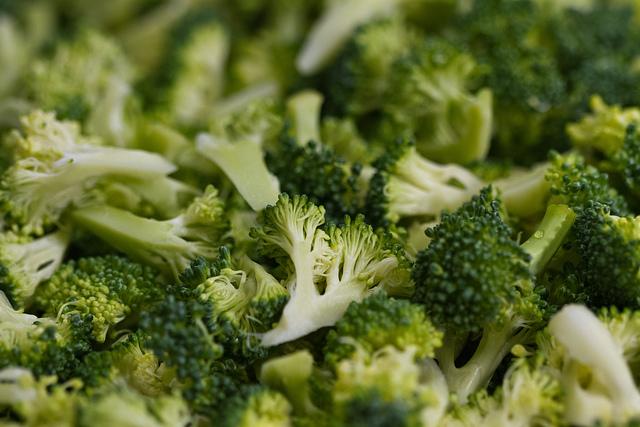Is there sauce on the broccoli?
Write a very short answer. No. How many bugs are in this picture?
Be succinct. 0. Is this a fruit?
Write a very short answer. No. What kind of food is this?
Give a very brief answer. Broccoli. Is there ice in the image?
Write a very short answer. No. Is the broccoli fresh?
Write a very short answer. Yes. What vegetable is this?
Answer briefly. Broccoli. Are the veggies cooked?
Give a very brief answer. No. Are these vegetables sliced?
Concise answer only. Yes. 